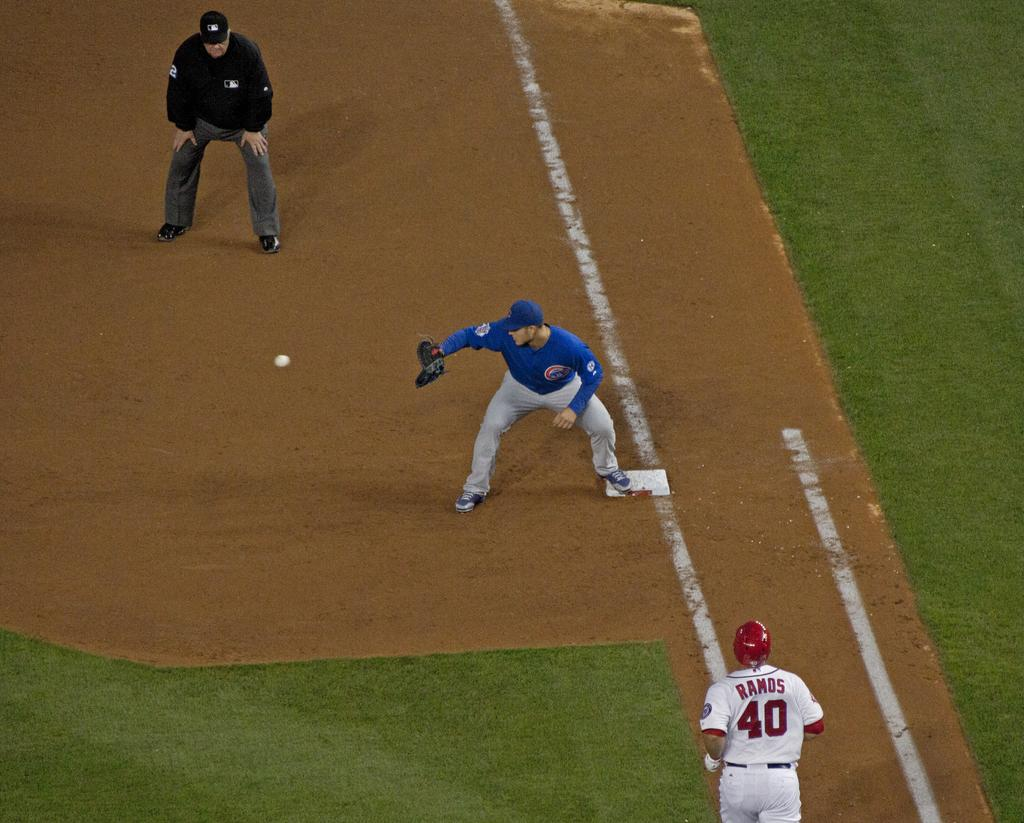<image>
Provide a brief description of the given image. Professional baseball player Ramos number fourth running to first base. 